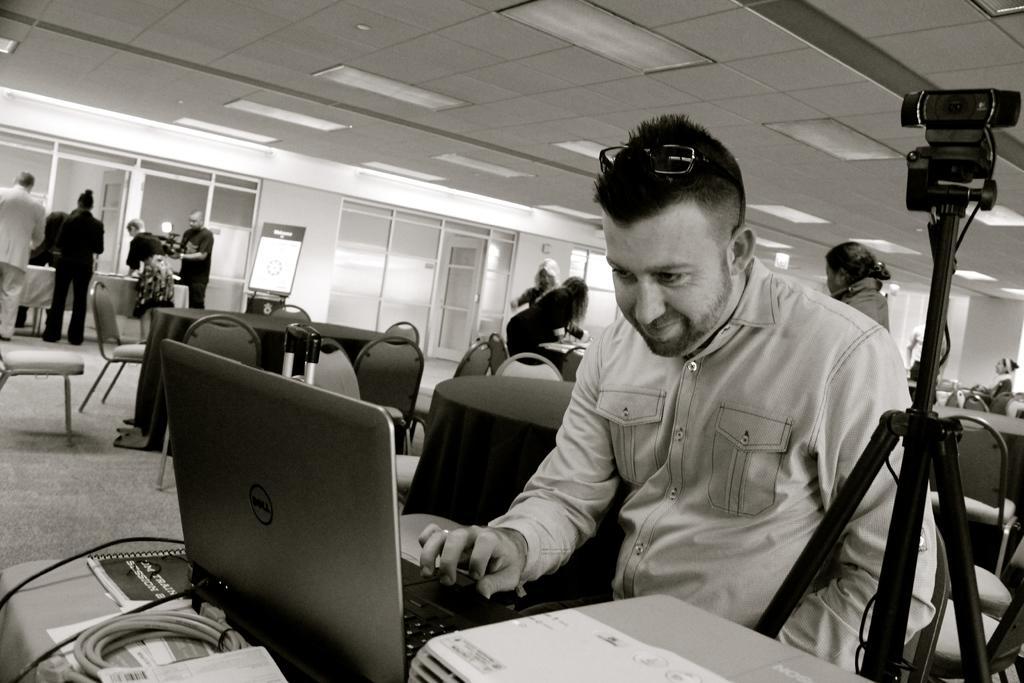Could you give a brief overview of what you see in this image? This image consists of a man using a laptop. In front of him, there is a printer and a table. Beside him, there is a camera along with a tripod. In the background, there are many people along with tables and chairs. 